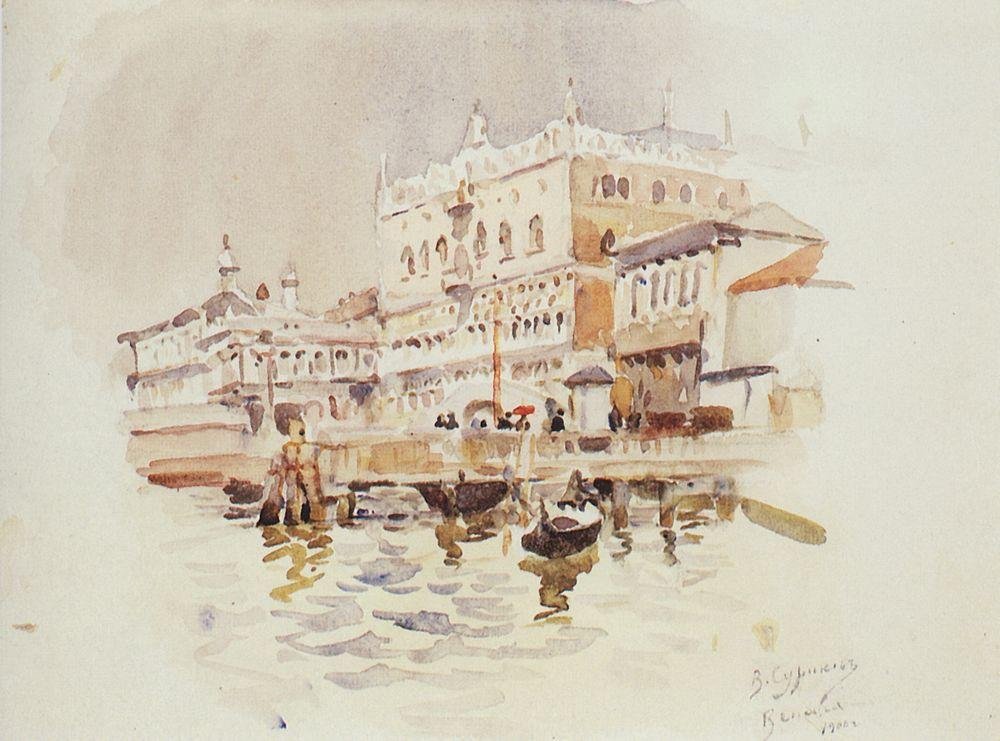Can you describe the architecture of the buildings in this painting? The buildings in the painting are fine examples of Venetian architecture. They exhibit a harmonious blend of Gothic and Renaissance elements, with intricate details adorning the facades. The windows are framed by elegant arches, and the rooflines are embellished with decorative features like pinnacles and statues. The white color of the buildings adds a touch of elegance, while the red roof provides a striking contrast. Why do you think the artist chose an impressionistic style for this scene? The artist likely chose an impressionistic style to capture the fleeting beauty and vibrant atmosphere of Venice. This style allows for a focus on light and color, which are crucial elements in conveying the unique ambiance of the city. By using softer, diffused edges and emphasizing the interplay of light on the water and buildings, the artist creates a sense of movement and liveliness, which enhances the viewer's emotional connection to the scene. What might it feel like to be on one of those boats? Riding one of the boats in the painting would likely be an enchanting experience. You would feel the gentle sway of the vessel as it glides through the calm waters of the Grand Canal. The sound of the water lapping against the boat and the occasional distant chatter from the people on the canal would create a serene yet lively ambiance. The view of the majestic palaces and the intricate details of the architecture up close would be awe-inspiring. The bright, sunlit day would enhance the vibrant colors of the surroundings, making the experience even more vivid and memorable. 